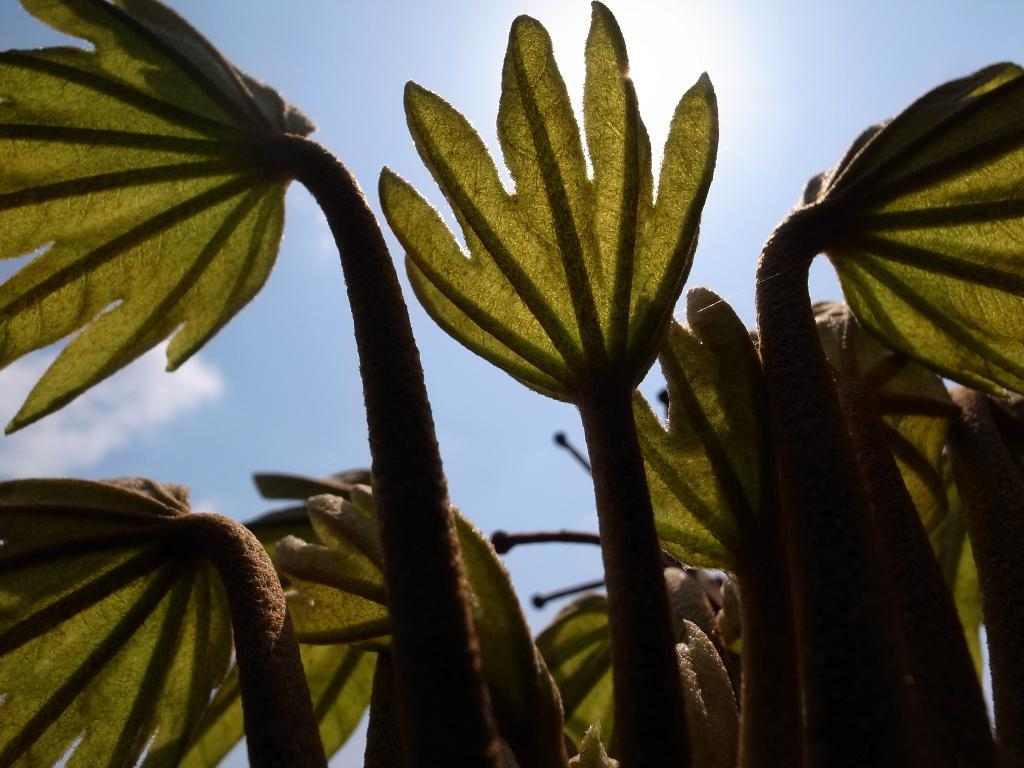What type of vegetation is present in the image? There are green color leaves in the image. What can be seen in the background of the image? The background of the image includes a blue color sky. What else is visible in the sky? Clouds are visible in the sky. What type of sweater is being worn by the clouds in the image? There are no people or clothing items present in the image, as it only features leaves, sky, and clouds. 